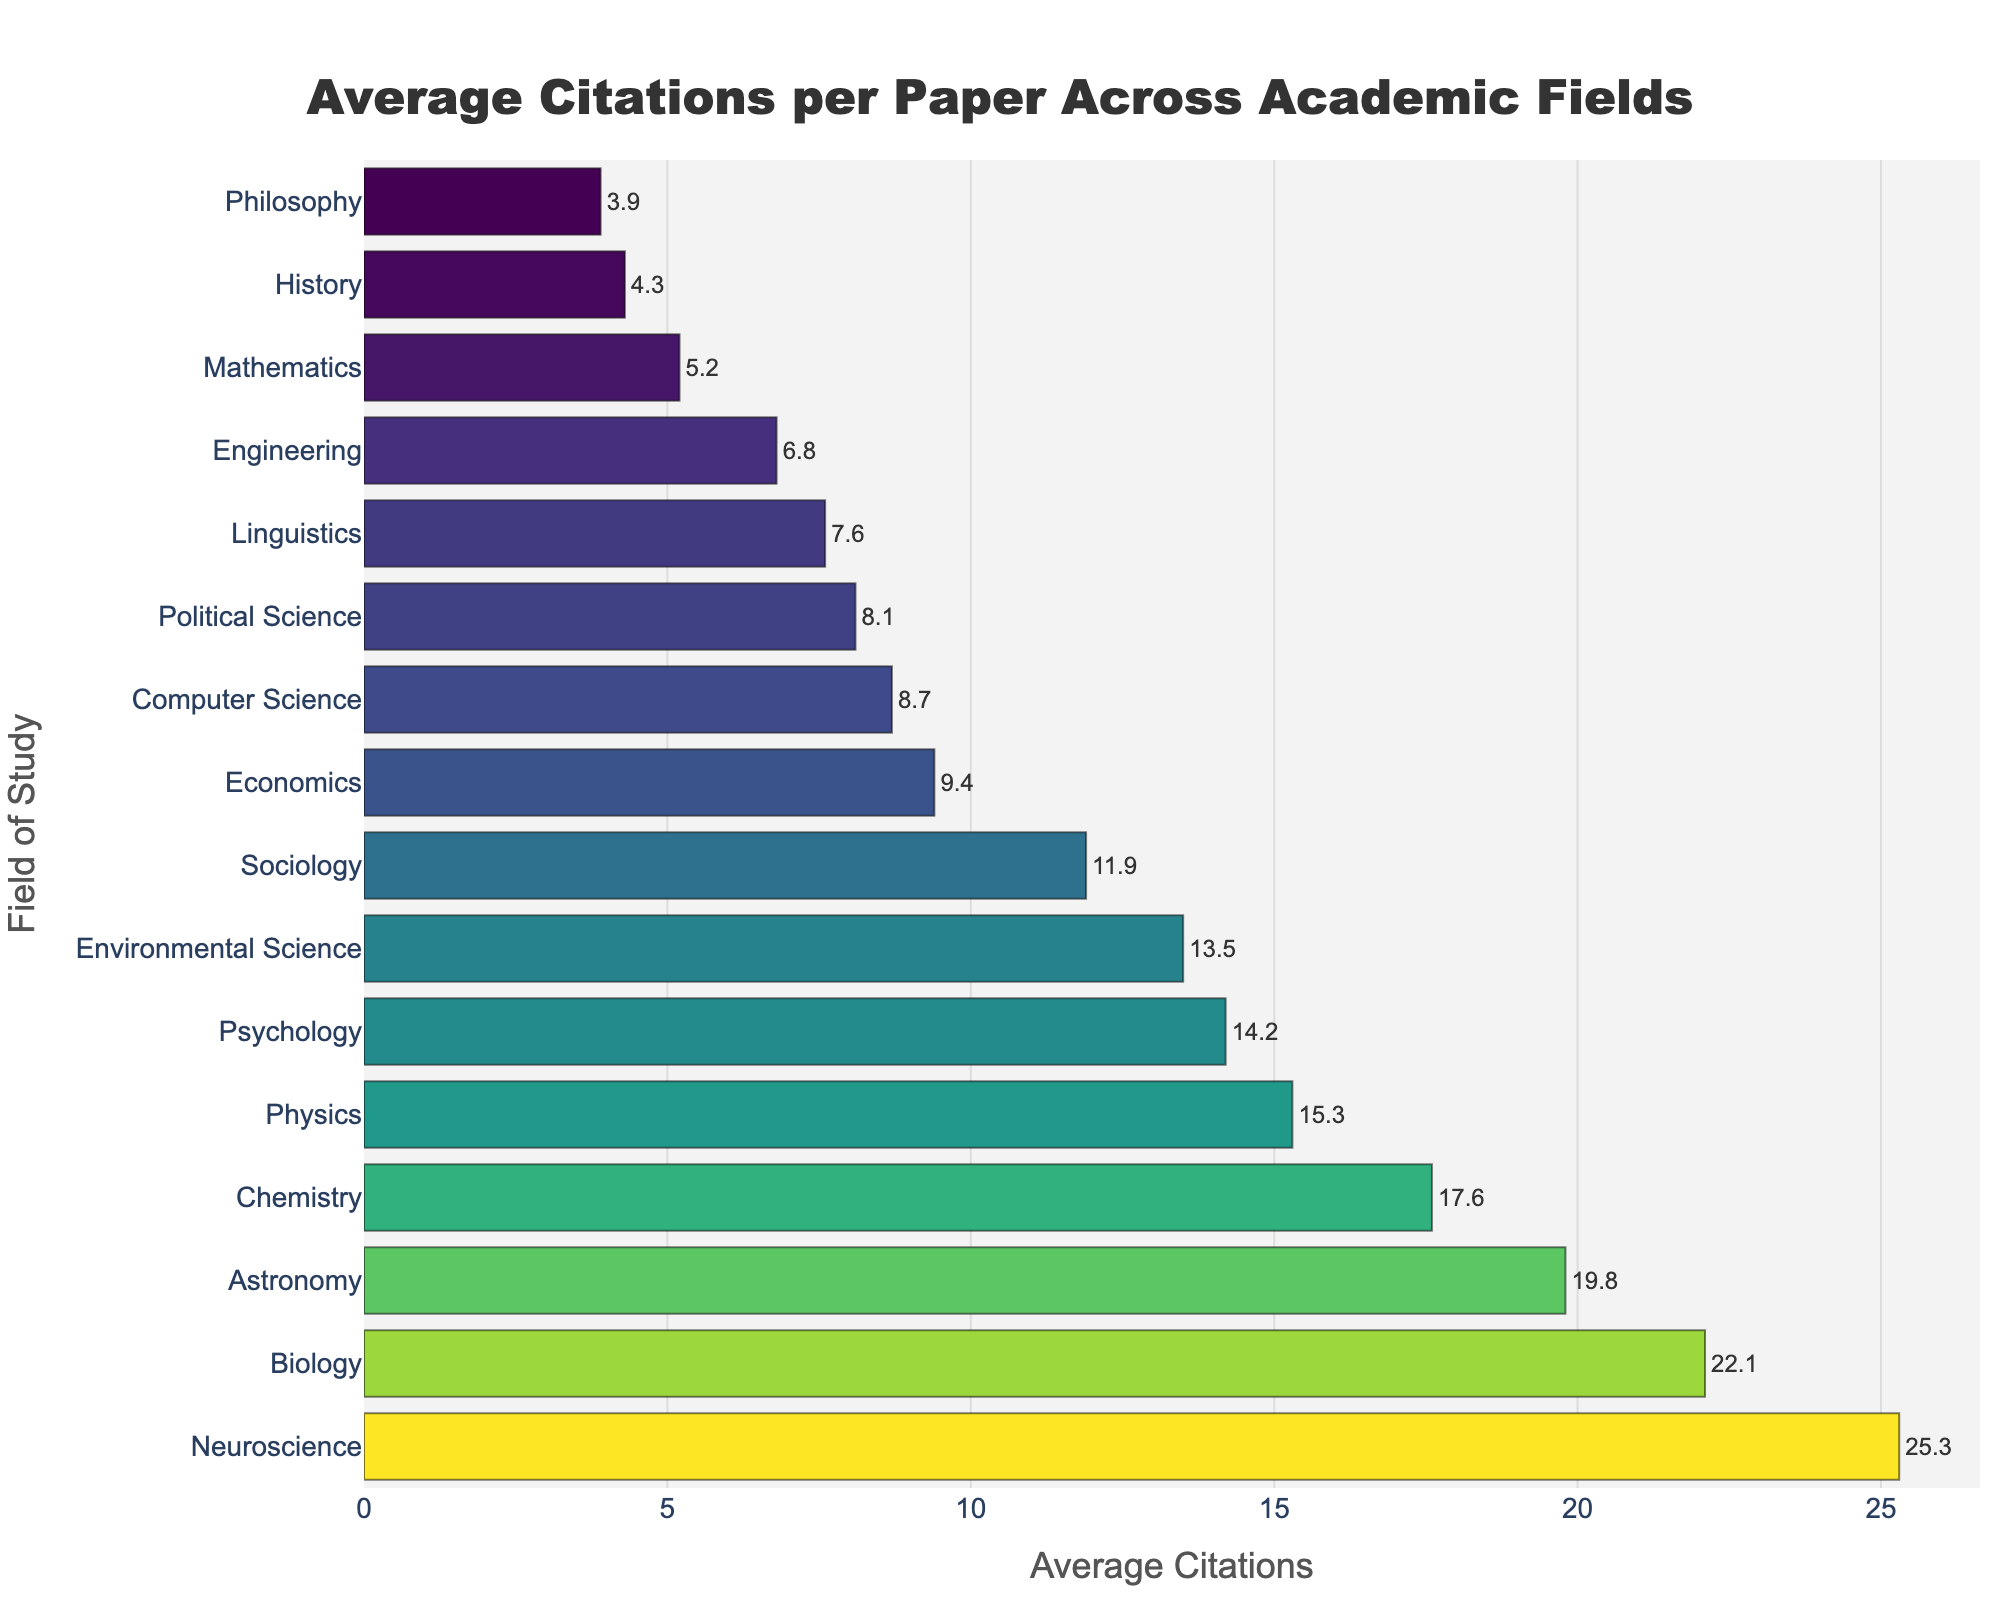Which field has the highest average citations per paper? The field with the highest average citations per paper is displayed at the top of the bar chart, indicating the most citations.
Answer: Neuroscience Which two fields have the lowest average citations per paper? The two fields with the lowest average citations per paper are found at the bottom of the bar chart, representing the least citations.
Answer: Philosophy, History How does the average citation count for Computer Science compare to that of Mathematics? Compare the heights of the bars corresponding to Computer Science and Mathematics to determine how their average citation counts differ.
Answer: Computer Science has more citations than Mathematics What is the difference in average citations per paper between Chemistry and Sociology? Subtract the average citations per paper for Sociology from that for Chemistry (17.6 - 11.9).
Answer: 5.7 What is the sum of average citations per paper for Physics, Chemistry, and Biology? Add the average citations per paper for Physics (15.3), Chemistry (17.6), and Biology (22.1) together (15.3 + 17.6 + 22.1).
Answer: 55 Which fields have an average citation count higher than 10 but lower than 20? Identify all fields on the bar chart where the average citation count is between 10 and 20.
Answer: Physics, Chemistry, Psychology, Sociology, Environmental Science, Astronomy Compare the average citations per paper for Political Science and Economics. Which one has more citations? Compare the bar lengths for Political Science and Economics to determine which has more citations.
Answer: Economics What is the combined average citation count for Engineering and History? Add the average citations per paper for Engineering (6.8) and History (4.3) together (6.8 + 4.3).
Answer: 11.1 Which fields have an average citation count below 10? Identify all fields on the bar chart where the average citation count is less than 10.
Answer: Computer Science, Economics, Engineering, Mathematics, Linguistics, History, Philosophy, Political Science What is the visual difference in bar color between the fields with the highest and the lowest average citations per paper? Observe and describe the color difference between the fields with the highest (Neuroscience) and the lowest (Philosophy) average citations per paper.
Answer: Neuroscience's bar is a bright color while Philosophy's bar is a darker color 